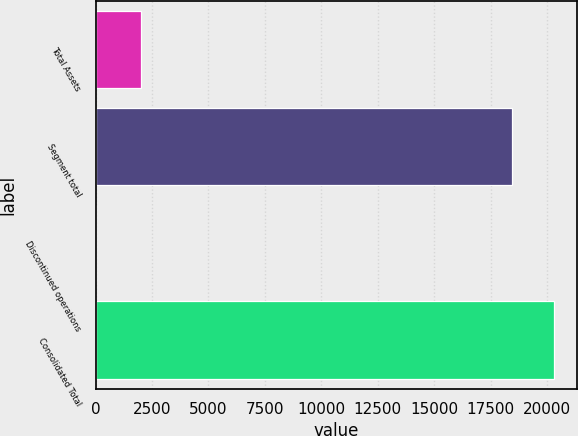<chart> <loc_0><loc_0><loc_500><loc_500><bar_chart><fcel>Total Assets<fcel>Segment total<fcel>Discontinued operations<fcel>Consolidated Total<nl><fcel>2017<fcel>18457<fcel>10.2<fcel>20302.7<nl></chart> 